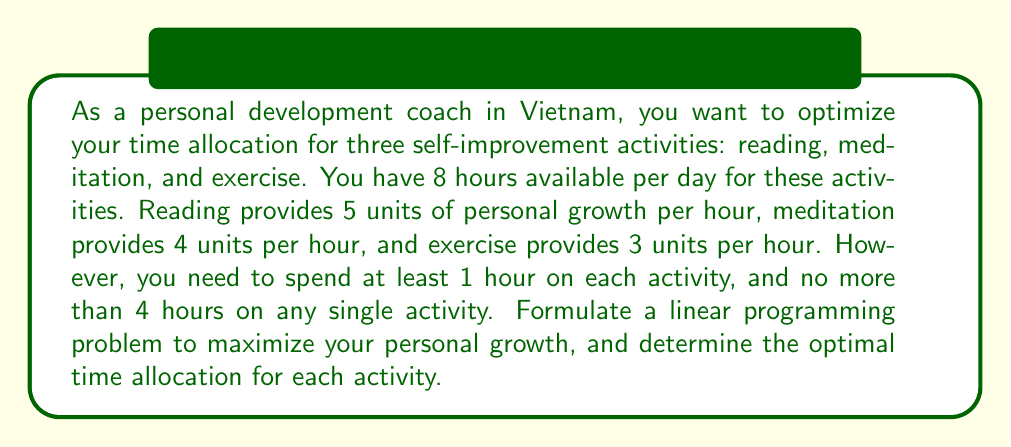Teach me how to tackle this problem. Let's approach this problem step-by-step using linear programming:

1. Define the variables:
   Let $x$ = hours spent reading
   Let $y$ = hours spent meditating
   Let $z$ = hours spent exercising

2. Objective function:
   We want to maximize personal growth, which is represented by:
   $$ \text{Maximize } 5x + 4y + 3z $$

3. Constraints:
   a) Total time constraint: $x + y + z \leq 8$
   b) Minimum time for each activity: $x \geq 1$, $y \geq 1$, $z \geq 1$
   c) Maximum time for each activity: $x \leq 4$, $y \leq 4$, $z \leq 4$

4. Now we have our complete linear programming problem:

   $$ \begin{align*}
   \text{Maximize: } & 5x + 4y + 3z \\
   \text{Subject to: } & x + y + z \leq 8 \\
   & 1 \leq x \leq 4 \\
   & 1 \leq y \leq 4 \\
   & 1 \leq z \leq 4 \\
   & x, y, z \geq 0
   \end{align*} $$

5. To solve this, we can use the simplex method or a graphical approach. However, given the constraints, we can deduce that we should allocate more time to activities with higher personal growth units per hour.

6. The optimal solution will allocate the maximum time (4 hours) to reading, which has the highest growth rate. The remaining 4 hours should be split between meditation and exercise, with more time given to meditation due to its higher growth rate.

7. Therefore, the optimal allocation is:
   Reading (x) = 4 hours
   Meditation (y) = 3 hours
   Exercise (z) = 1 hour

8. We can verify that this satisfies all constraints:
   4 + 3 + 1 = 8 (total time constraint)
   All activities are between 1 and 4 hours

9. The maximum personal growth achieved is:
   $$ 5(4) + 4(3) + 3(1) = 20 + 12 + 3 = 35 \text{ units} $$
Answer: The optimal time allocation is 4 hours for reading, 3 hours for meditation, and 1 hour for exercise, resulting in a maximum personal growth of 35 units. 